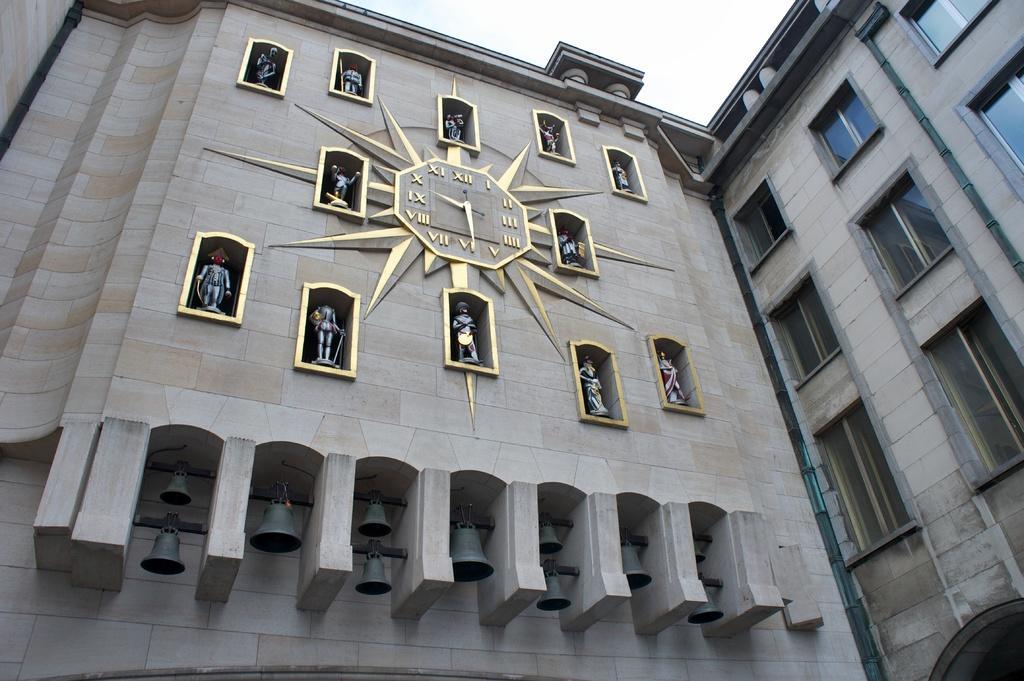Can you describe this image briefly? Here we can see a building, clock, sculptures, and bells. In the background there is sky. 